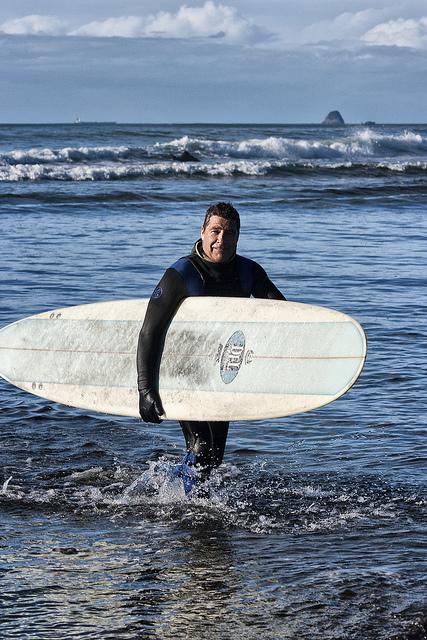What sport is shown?
Short answer required. Surfing. Does this man use sex wax on his surfboard?
Write a very short answer. No. What is the man carrying?
Keep it brief. Surfboard. 